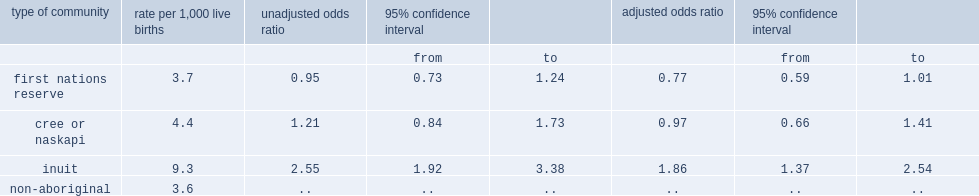Was neonatal mortality higher for inuit or for non-aboriginal people? Inuit. 